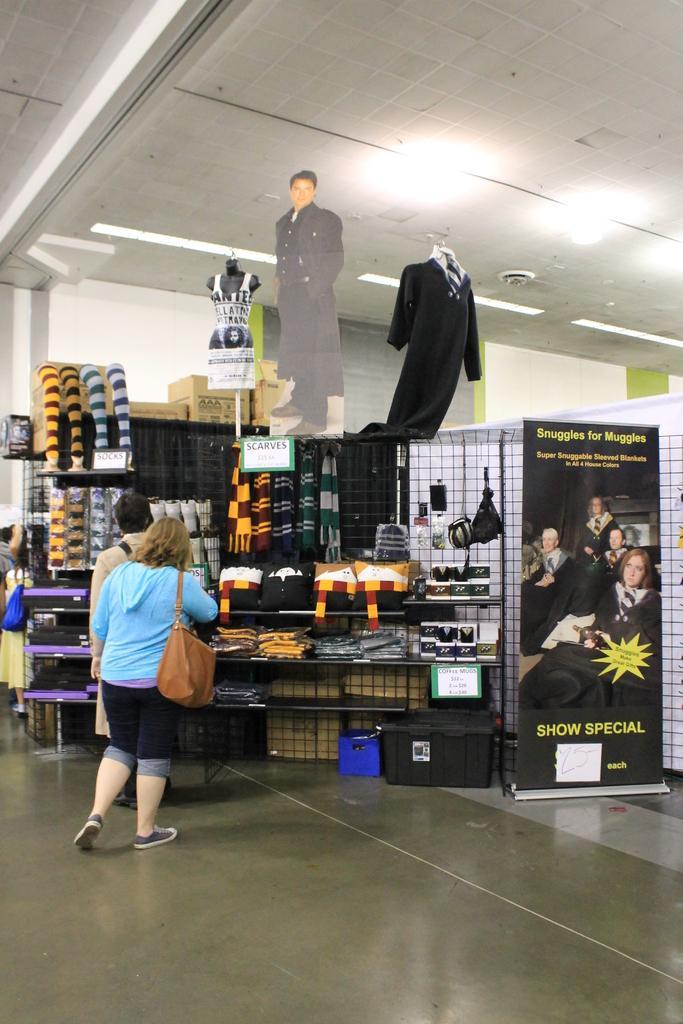How would you summarize this image in a sentence or two? In this image, we can see two persons standing in front of the stall contains some clothes. There is a banner on the right side of the image. There are lights on the ceiling which is at the top of the image. 